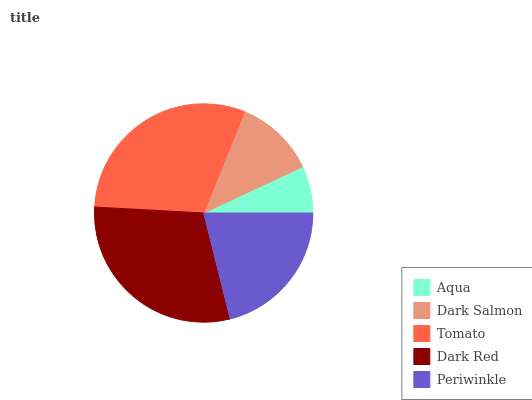Is Aqua the minimum?
Answer yes or no. Yes. Is Tomato the maximum?
Answer yes or no. Yes. Is Dark Salmon the minimum?
Answer yes or no. No. Is Dark Salmon the maximum?
Answer yes or no. No. Is Dark Salmon greater than Aqua?
Answer yes or no. Yes. Is Aqua less than Dark Salmon?
Answer yes or no. Yes. Is Aqua greater than Dark Salmon?
Answer yes or no. No. Is Dark Salmon less than Aqua?
Answer yes or no. No. Is Periwinkle the high median?
Answer yes or no. Yes. Is Periwinkle the low median?
Answer yes or no. Yes. Is Dark Salmon the high median?
Answer yes or no. No. Is Dark Red the low median?
Answer yes or no. No. 